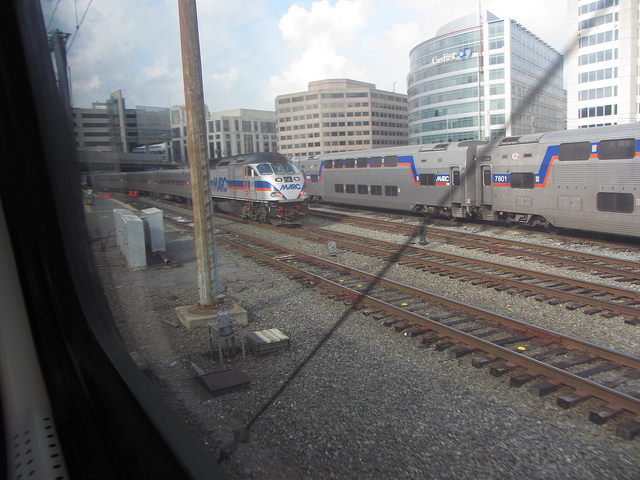Please extract the text content from this image. MRC 1801 